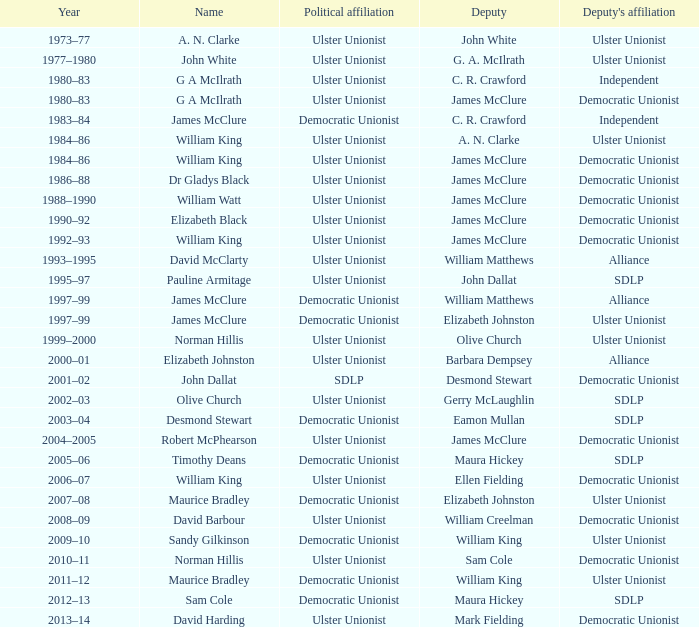What is the Political affiliation of deputy john dallat? Ulster Unionist. 